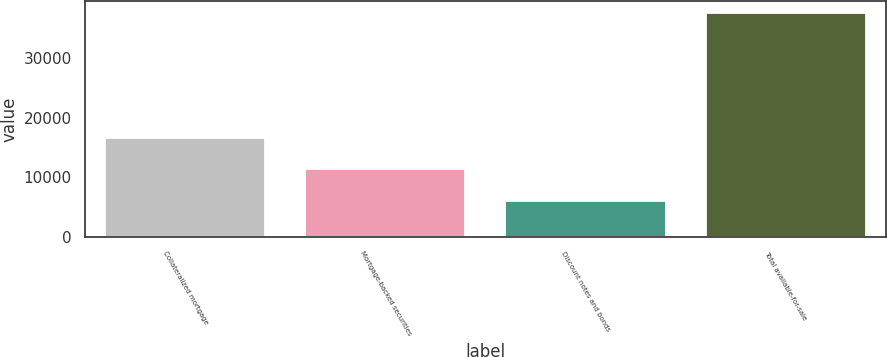Convert chart to OTSL. <chart><loc_0><loc_0><loc_500><loc_500><bar_chart><fcel>Collateralized mortgage<fcel>Mortgage-backed securities<fcel>Discount notes and bonds<fcel>Total available-for-sale<nl><fcel>16547<fcel>11440<fcel>6117<fcel>37597<nl></chart> 